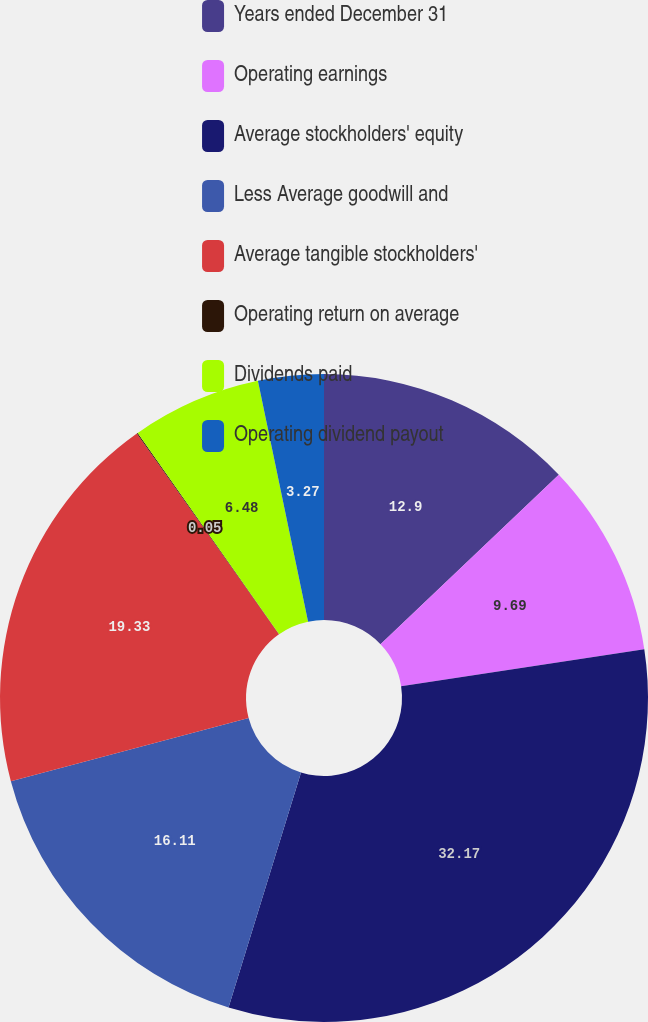Convert chart to OTSL. <chart><loc_0><loc_0><loc_500><loc_500><pie_chart><fcel>Years ended December 31<fcel>Operating earnings<fcel>Average stockholders' equity<fcel>Less Average goodwill and<fcel>Average tangible stockholders'<fcel>Operating return on average<fcel>Dividends paid<fcel>Operating dividend payout<nl><fcel>12.9%<fcel>9.69%<fcel>32.17%<fcel>16.11%<fcel>19.33%<fcel>0.05%<fcel>6.48%<fcel>3.27%<nl></chart> 